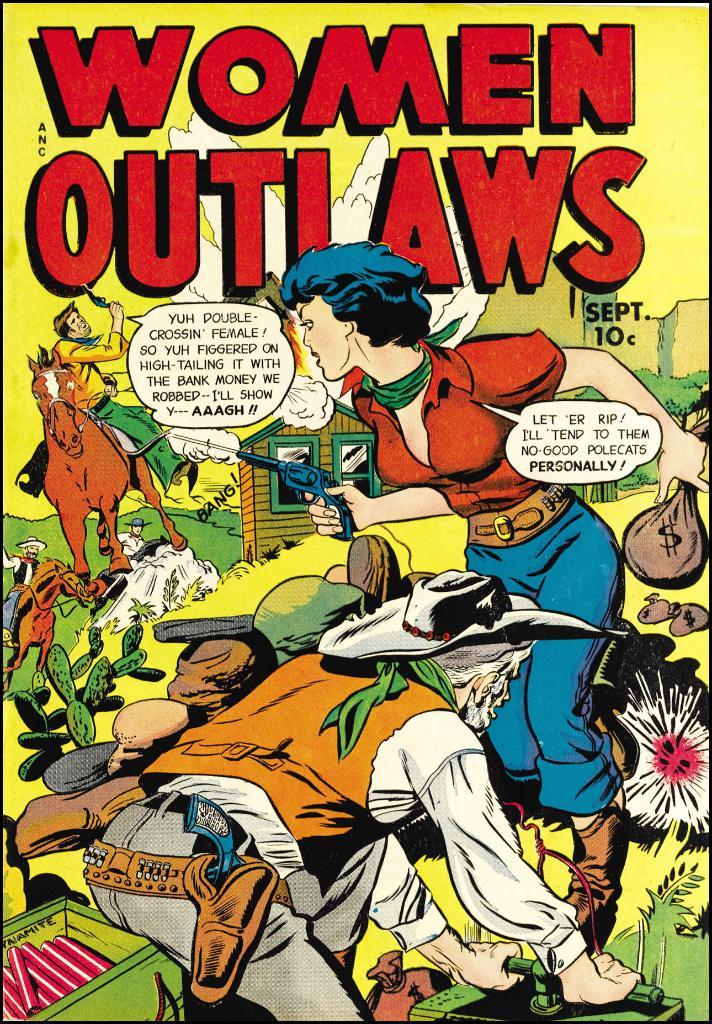Is this comic really old?
Give a very brief answer. Yes. 